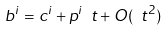<formula> <loc_0><loc_0><loc_500><loc_500>b ^ { i } = c ^ { i } + p ^ { i } \ t + O ( \ t ^ { 2 } ) \,</formula> 